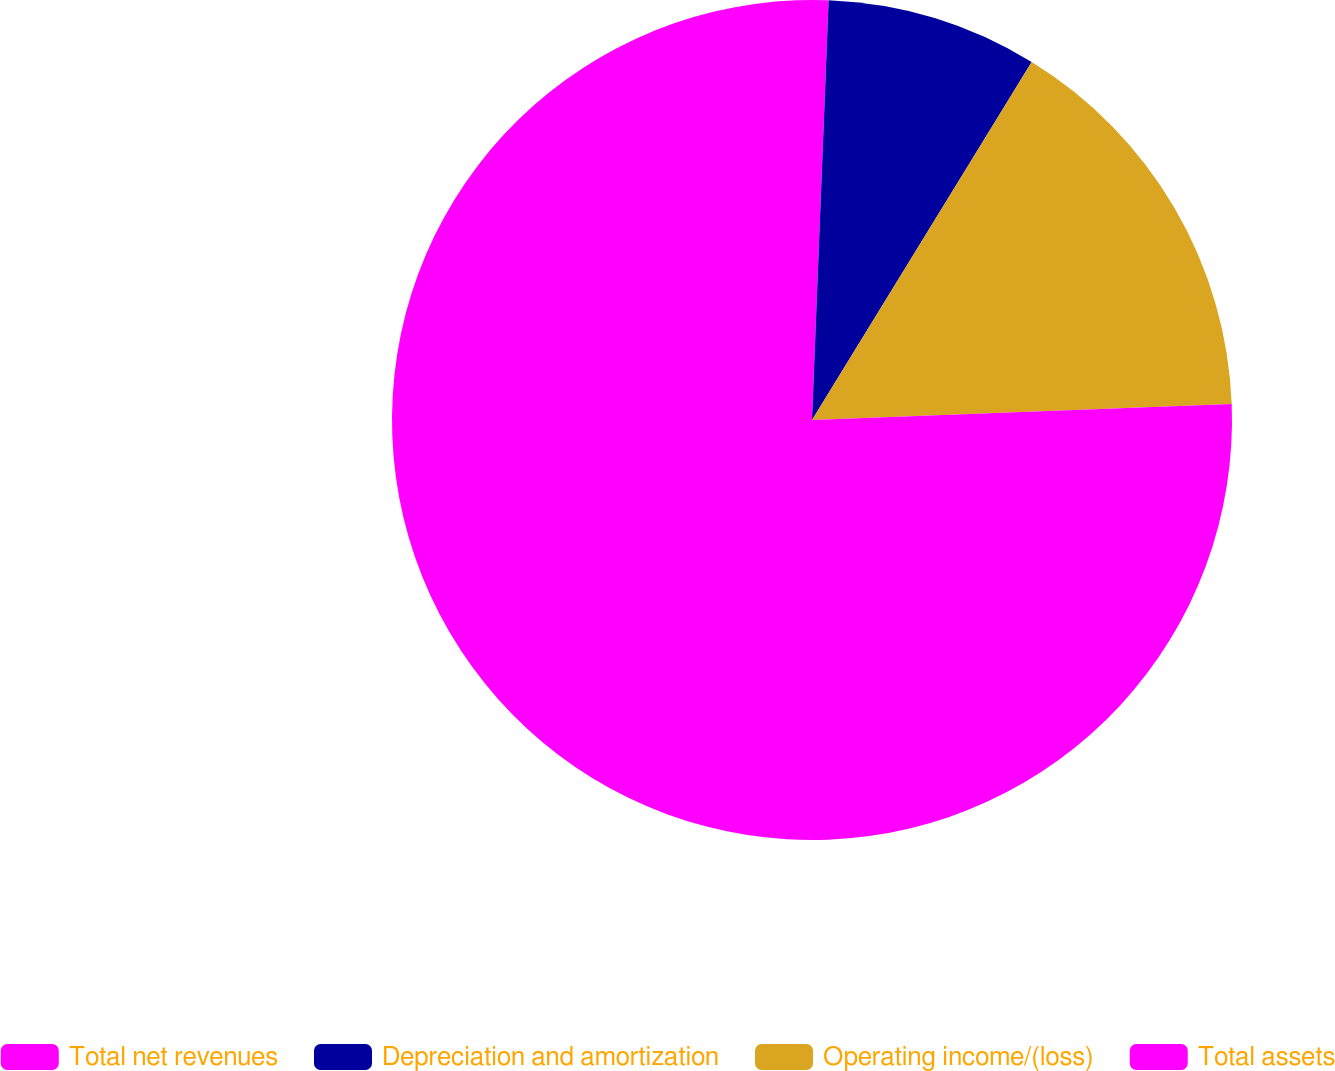Convert chart. <chart><loc_0><loc_0><loc_500><loc_500><pie_chart><fcel>Total net revenues<fcel>Depreciation and amortization<fcel>Operating income/(loss)<fcel>Total assets<nl><fcel>0.63%<fcel>8.13%<fcel>15.63%<fcel>75.61%<nl></chart> 